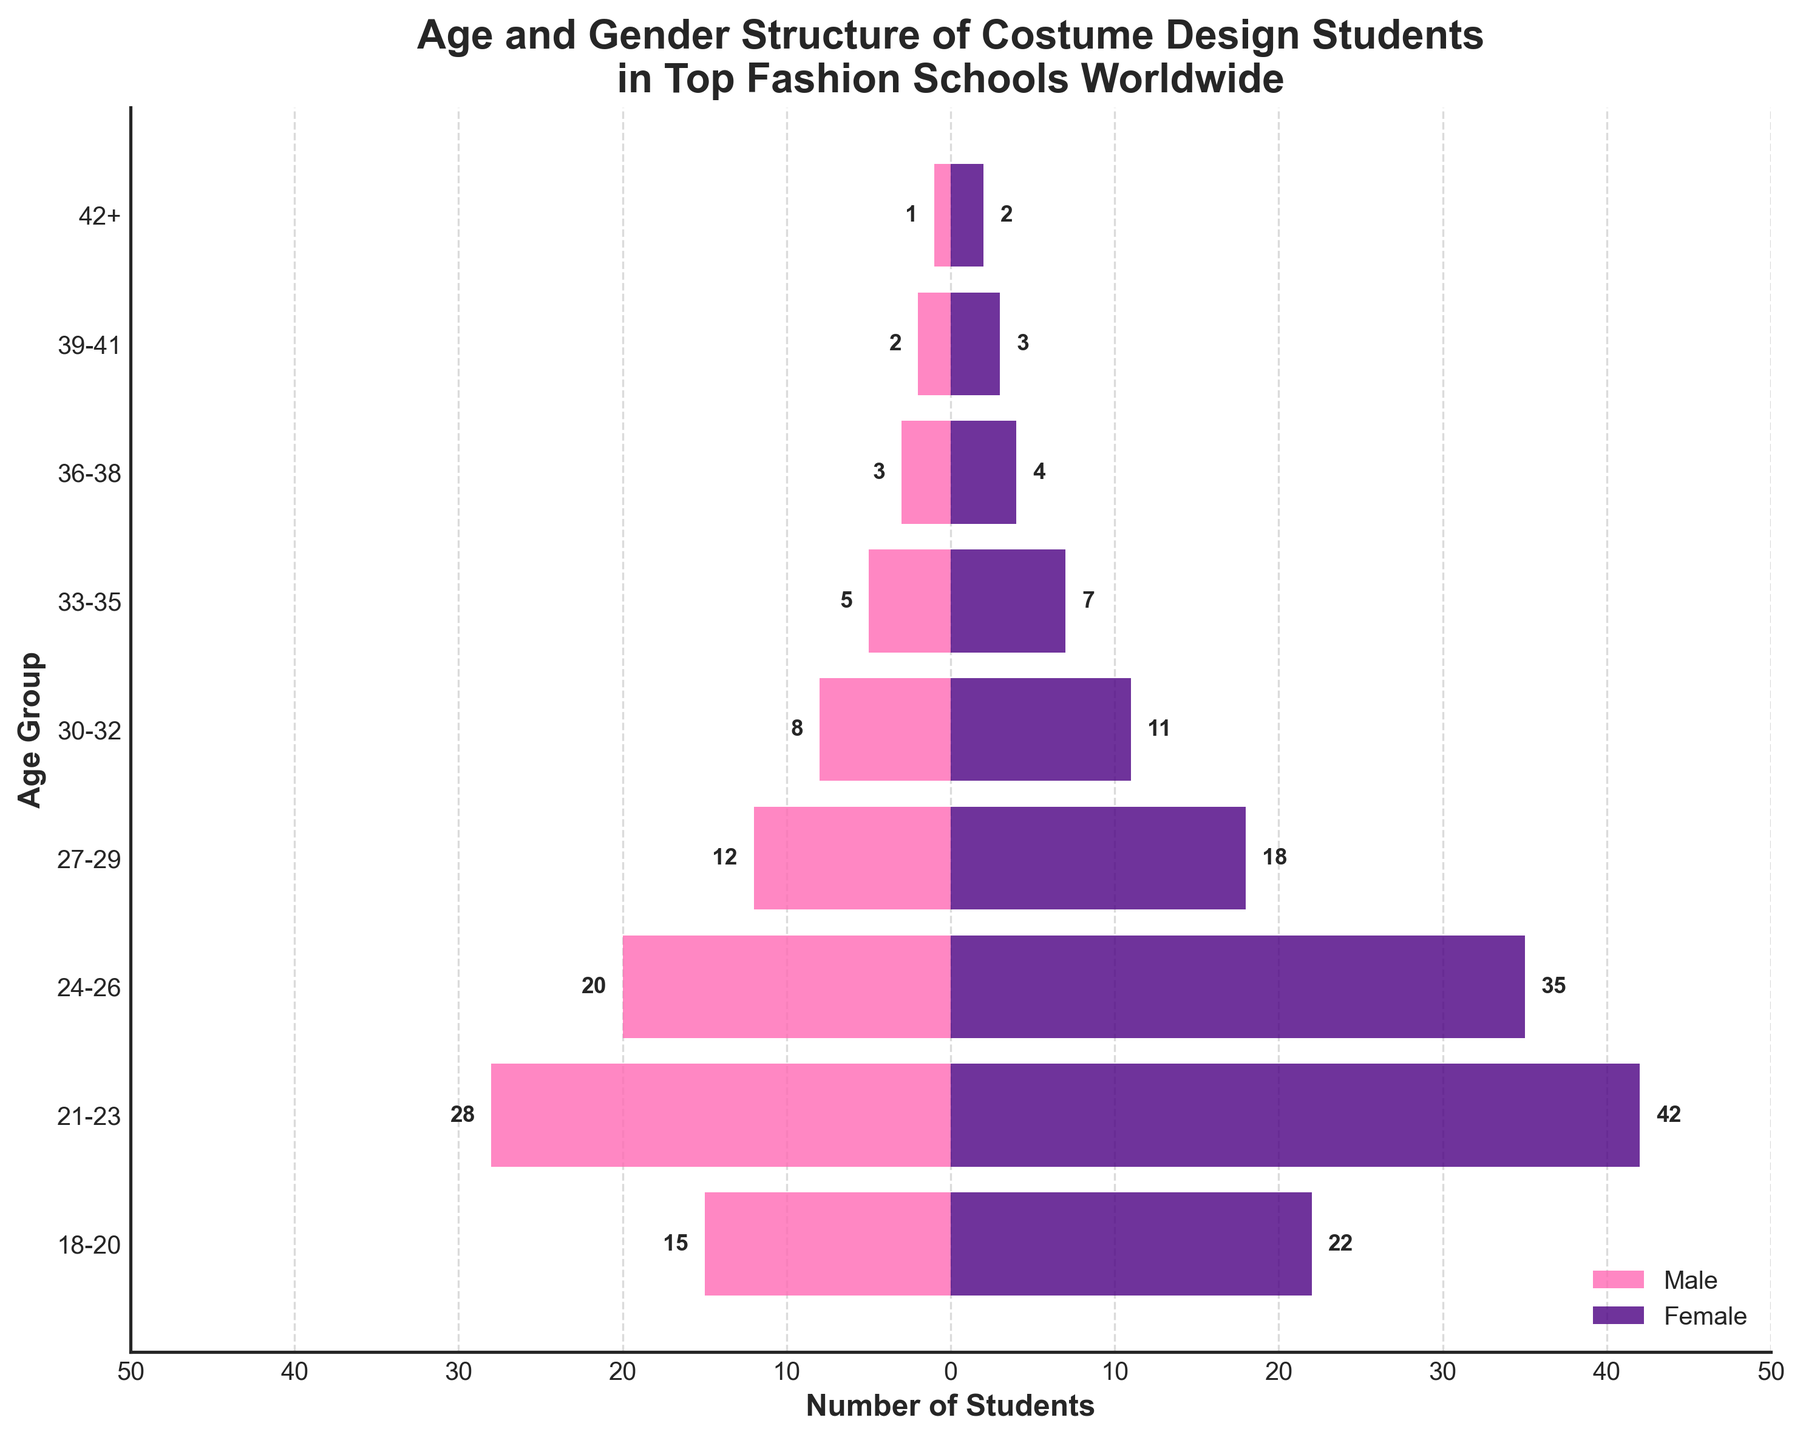What is the name of the chart? The title of the chart is located at the top of the figure. It reads "Age and Gender Structure of Costume Design Students in Top Fashion Schools Worldwide."
Answer: Age and Gender Structure of Costume Design Students in Top Fashion Schools Worldwide How many age groups are represented in the figure? The y-axis of the figure lists the age groups. Counting the number of age groups yields 9.
Answer: 9 In the 21-23 age group, how many more females are there than males? From the figure, the 21-23 age group has 42 females and 28 males. The difference between females and males is 42 - 28.
Answer: 14 Which age group has the largest number of female students? Examining each bar on the right side (female), the 21-23 age group has the longest bar, representing 42 students.
Answer: 21-23 What is the combined number of male students in the age groups from 18-20 and 21-23? The number of male students in the 18-20 age group is 15, and in the 21-23 age group, it is 28. Adding these together, 15 + 28, gives the total.
Answer: 43 How does the number of students in the 24-26 age group compare between males and females? The figure shows that in the 24-26 age group, there are 20 male students and 35 female students. Therefore, females are more.
Answer: Females are more What is the total number of students aged 30 and above? Adding the number of students (Male + Female) for each age group from 30-32 to 42+: (8+11) + (5+7) + (3+4) + (2+3) + (1+2) = 46.
Answer: 46 Is there any age group with an equal number of male and female students? Checking each age group shows that no age group has equal numbers of male and female students.
Answer: No Which age group has the smallest number of students in total? Adding the total for each age group, the 42+ age group has the lowest total (1 Male + 2 Female) = 3.
Answer: 42+ Do males or females dominate in the population pyramid for costume design students? By examining the overall lengths of the bars on each side, females generally have longer bars, indicating more female students overall.
Answer: Females dominate 